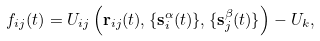Convert formula to latex. <formula><loc_0><loc_0><loc_500><loc_500>f _ { i j } ( t ) & = U _ { i j } \left ( \mathbf r _ { i j } ( t ) , \{ \mathbf s ^ { \alpha } _ { i } ( t ) \} , \{ \mathbf s ^ { \beta } _ { j } ( t ) \} \right ) - U _ { k } ,</formula> 